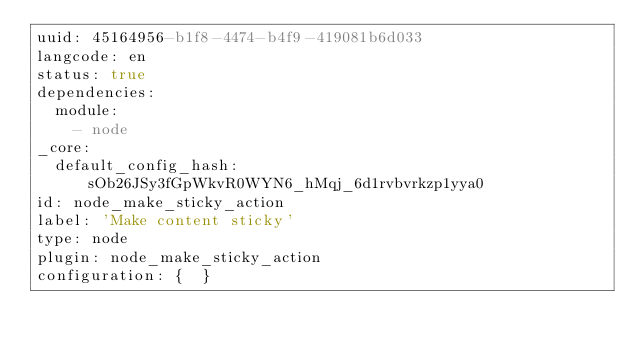<code> <loc_0><loc_0><loc_500><loc_500><_YAML_>uuid: 45164956-b1f8-4474-b4f9-419081b6d033
langcode: en
status: true
dependencies:
  module:
    - node
_core:
  default_config_hash: sOb26JSy3fGpWkvR0WYN6_hMqj_6d1rvbvrkzp1yya0
id: node_make_sticky_action
label: 'Make content sticky'
type: node
plugin: node_make_sticky_action
configuration: {  }
</code> 